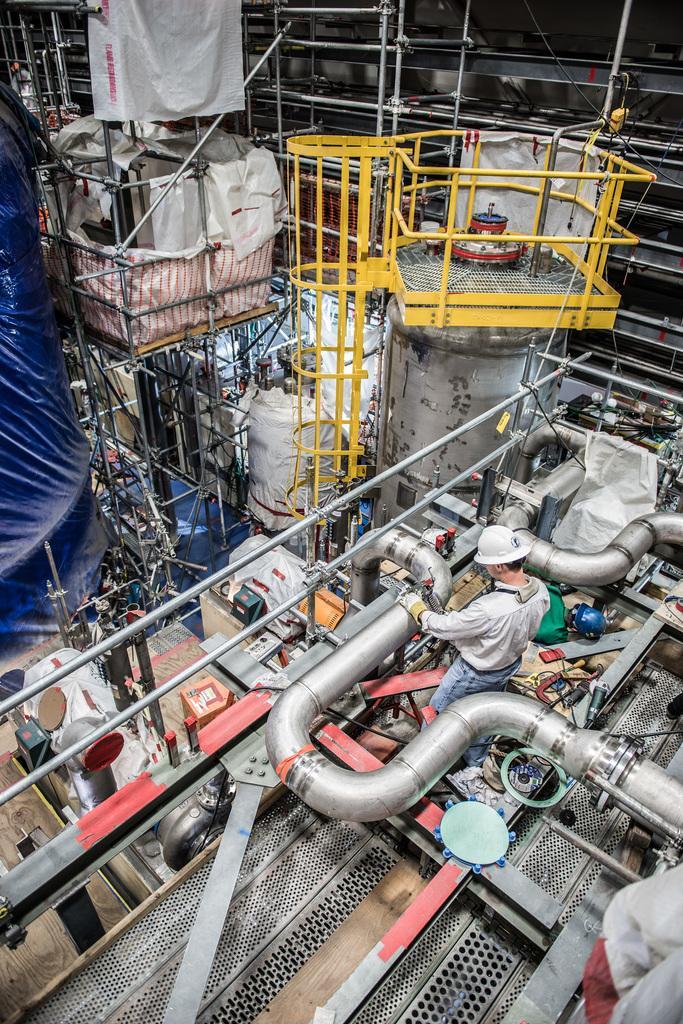Please provide a concise description of this image. This image is taken indoors. In this image there is a huge machinery, many pipes, grills and iron bars and a man is standing on the floor. In this image there are many things. 